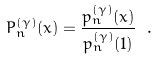<formula> <loc_0><loc_0><loc_500><loc_500>P _ { n } ^ { ( \gamma ) } ( x ) = \frac { p _ { n } ^ { ( \gamma ) } ( x ) } { p _ { n } ^ { ( \gamma ) } ( 1 ) } \ .</formula> 